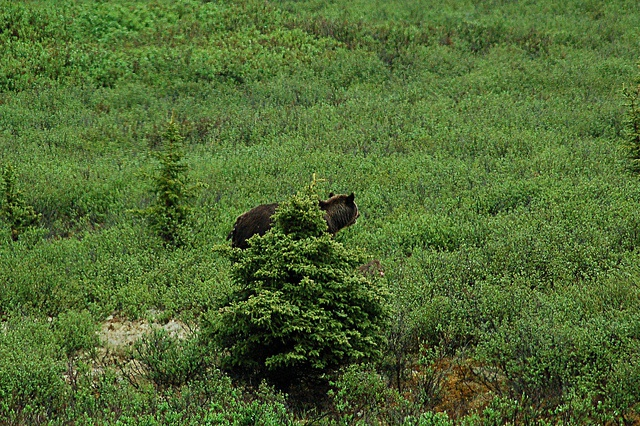Describe the objects in this image and their specific colors. I can see a bear in olive, black, and darkgreen tones in this image. 